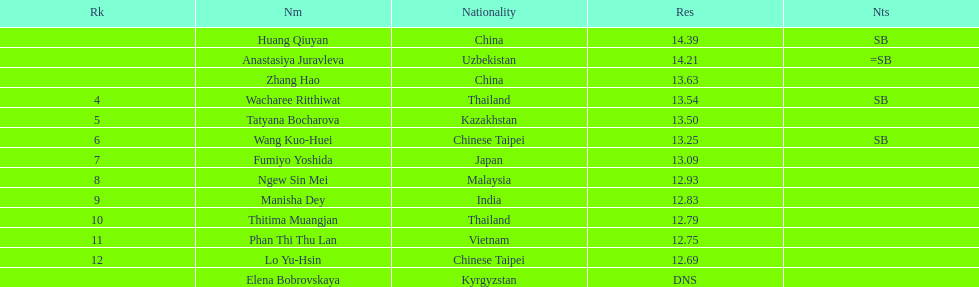What nationality was the woman who won first place? China. 